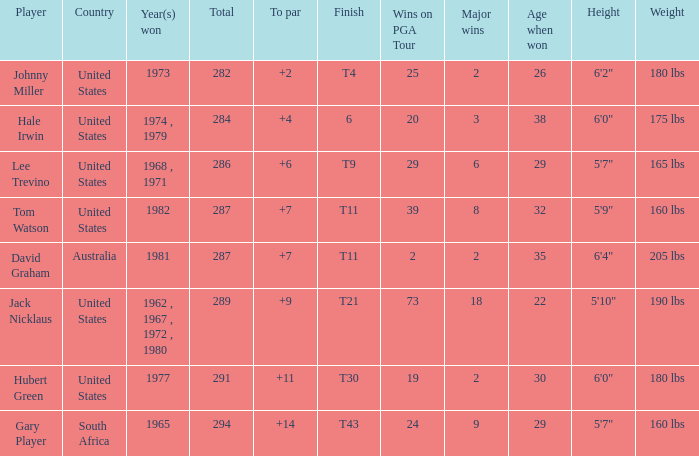WHAT IS THE TOTAL THAT HAS A WIN IN 1982? 287.0. 